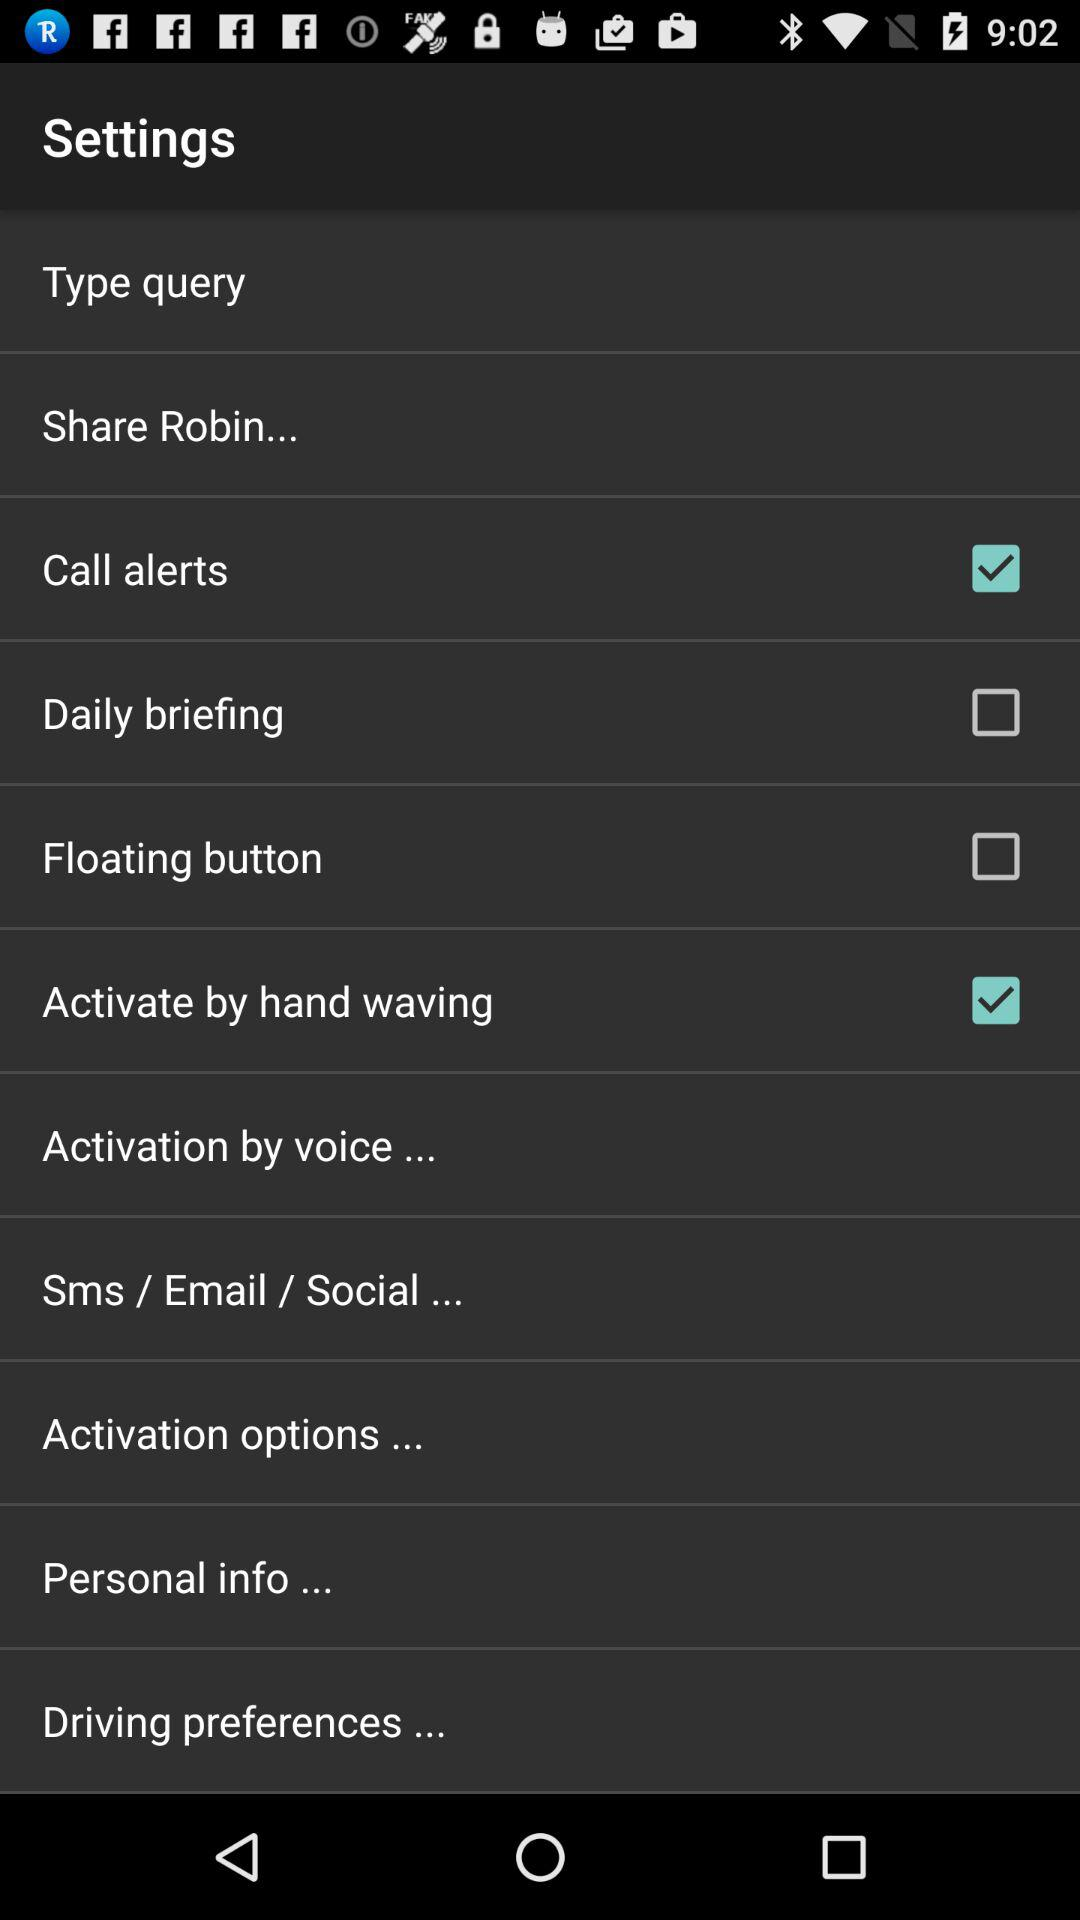What's the setting for the floating button? The status is off. 